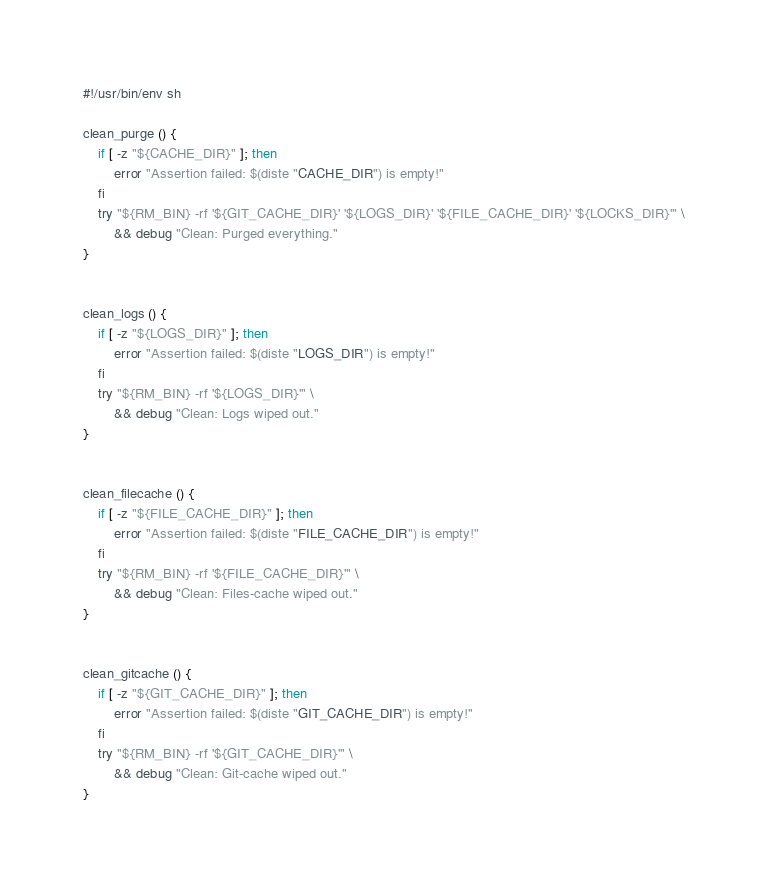<code> <loc_0><loc_0><loc_500><loc_500><_SML_>#!/usr/bin/env sh

clean_purge () {
    if [ -z "${CACHE_DIR}" ]; then
        error "Assertion failed: $(diste "CACHE_DIR") is empty!"
    fi
    try "${RM_BIN} -rf '${GIT_CACHE_DIR}' '${LOGS_DIR}' '${FILE_CACHE_DIR}' '${LOCKS_DIR}'" \
        && debug "Clean: Purged everything."
}


clean_logs () {
    if [ -z "${LOGS_DIR}" ]; then
        error "Assertion failed: $(diste "LOGS_DIR") is empty!"
    fi
    try "${RM_BIN} -rf '${LOGS_DIR}'" \
        && debug "Clean: Logs wiped out."
}


clean_filecache () {
    if [ -z "${FILE_CACHE_DIR}" ]; then
        error "Assertion failed: $(diste "FILE_CACHE_DIR") is empty!"
    fi
    try "${RM_BIN} -rf '${FILE_CACHE_DIR}'" \
        && debug "Clean: Files-cache wiped out."
}


clean_gitcache () {
    if [ -z "${GIT_CACHE_DIR}" ]; then
        error "Assertion failed: $(diste "GIT_CACHE_DIR") is empty!"
    fi
    try "${RM_BIN} -rf '${GIT_CACHE_DIR}'" \
        && debug "Clean: Git-cache wiped out."
}

</code> 